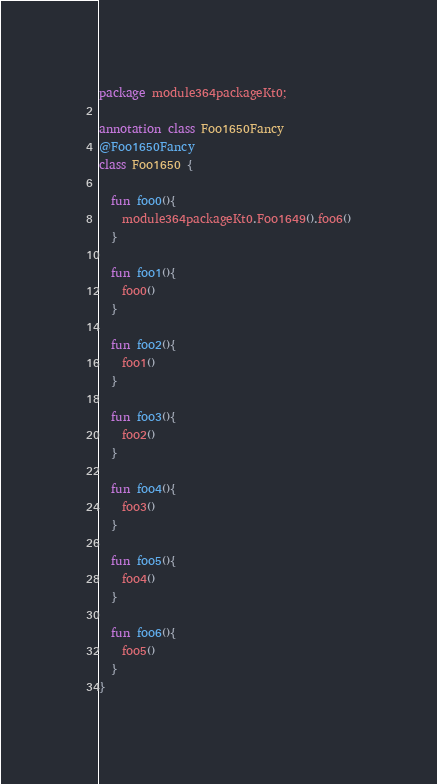Convert code to text. <code><loc_0><loc_0><loc_500><loc_500><_Kotlin_>package module364packageKt0;

annotation class Foo1650Fancy
@Foo1650Fancy
class Foo1650 {

  fun foo0(){
    module364packageKt0.Foo1649().foo6()
  }

  fun foo1(){
    foo0()
  }

  fun foo2(){
    foo1()
  }

  fun foo3(){
    foo2()
  }

  fun foo4(){
    foo3()
  }

  fun foo5(){
    foo4()
  }

  fun foo6(){
    foo5()
  }
}</code> 